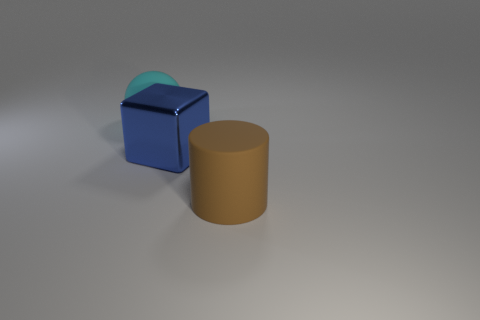Can you describe the lighting in the scene? The lighting in the scene appears diffuse, with soft shadows indicating an indirect light source, possibly overhead. This creates a gentle illumination with no harsh reflections, which contributes to the matte appearance of the objects. 